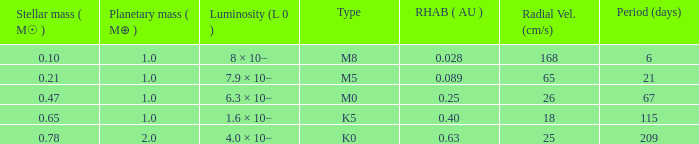What is the smallest period (days) to have a planetary mass of 1, a stellar mass greater than 0.21 and of the type M0? 67.0. 